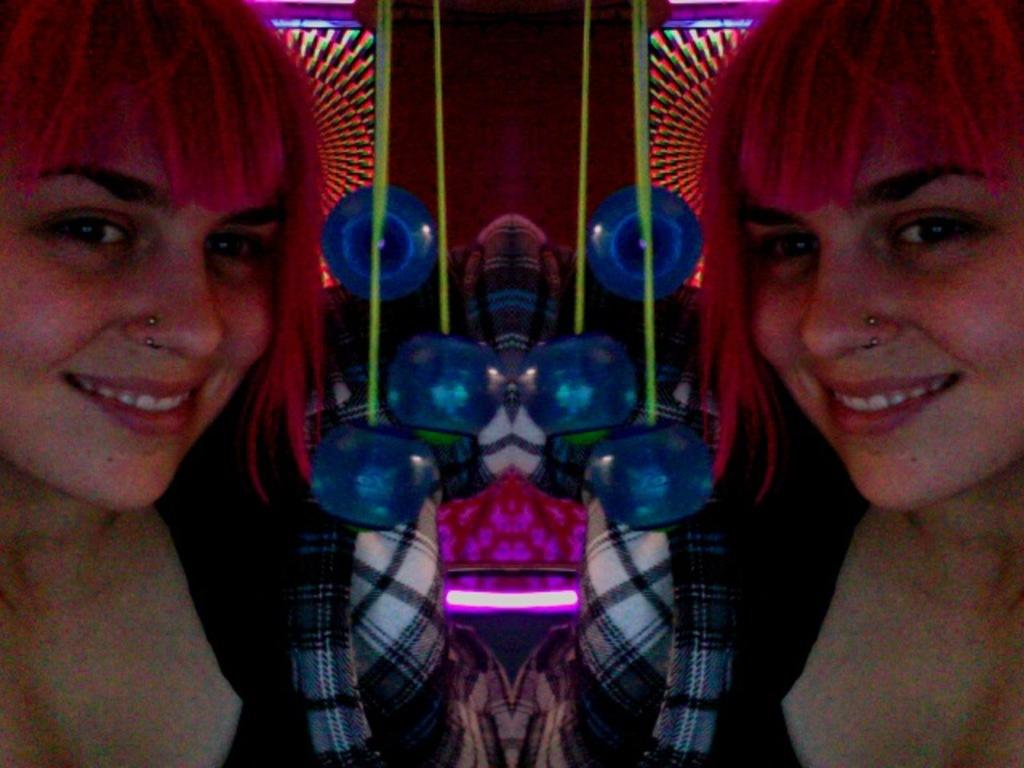What is unique about the image? The image contains a mirror reflection of itself on both sides. Can you describe the lady in the image? There is a lady smiling in the image. What else can be seen in the image besides the lady? There are other objects visible in the image. What type of lighting is present in the image? There are lights present in the image. What letter does the lady hold in her hand in the image? There is no letter visible in the lady's hand in the image. 